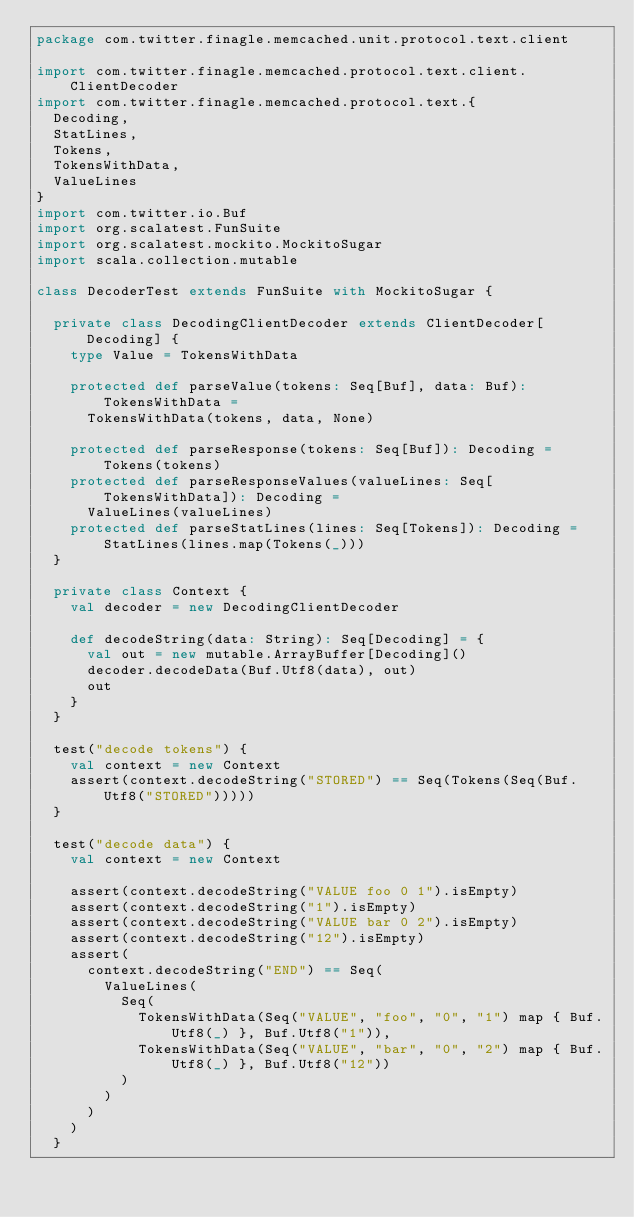<code> <loc_0><loc_0><loc_500><loc_500><_Scala_>package com.twitter.finagle.memcached.unit.protocol.text.client

import com.twitter.finagle.memcached.protocol.text.client.ClientDecoder
import com.twitter.finagle.memcached.protocol.text.{
  Decoding,
  StatLines,
  Tokens,
  TokensWithData,
  ValueLines
}
import com.twitter.io.Buf
import org.scalatest.FunSuite
import org.scalatest.mockito.MockitoSugar
import scala.collection.mutable

class DecoderTest extends FunSuite with MockitoSugar {

  private class DecodingClientDecoder extends ClientDecoder[Decoding] {
    type Value = TokensWithData

    protected def parseValue(tokens: Seq[Buf], data: Buf): TokensWithData =
      TokensWithData(tokens, data, None)

    protected def parseResponse(tokens: Seq[Buf]): Decoding = Tokens(tokens)
    protected def parseResponseValues(valueLines: Seq[TokensWithData]): Decoding =
      ValueLines(valueLines)
    protected def parseStatLines(lines: Seq[Tokens]): Decoding = StatLines(lines.map(Tokens(_)))
  }

  private class Context {
    val decoder = new DecodingClientDecoder

    def decodeString(data: String): Seq[Decoding] = {
      val out = new mutable.ArrayBuffer[Decoding]()
      decoder.decodeData(Buf.Utf8(data), out)
      out
    }
  }

  test("decode tokens") {
    val context = new Context
    assert(context.decodeString("STORED") == Seq(Tokens(Seq(Buf.Utf8("STORED")))))
  }

  test("decode data") {
    val context = new Context

    assert(context.decodeString("VALUE foo 0 1").isEmpty)
    assert(context.decodeString("1").isEmpty)
    assert(context.decodeString("VALUE bar 0 2").isEmpty)
    assert(context.decodeString("12").isEmpty)
    assert(
      context.decodeString("END") == Seq(
        ValueLines(
          Seq(
            TokensWithData(Seq("VALUE", "foo", "0", "1") map { Buf.Utf8(_) }, Buf.Utf8("1")),
            TokensWithData(Seq("VALUE", "bar", "0", "2") map { Buf.Utf8(_) }, Buf.Utf8("12"))
          )
        )
      )
    )
  }
</code> 